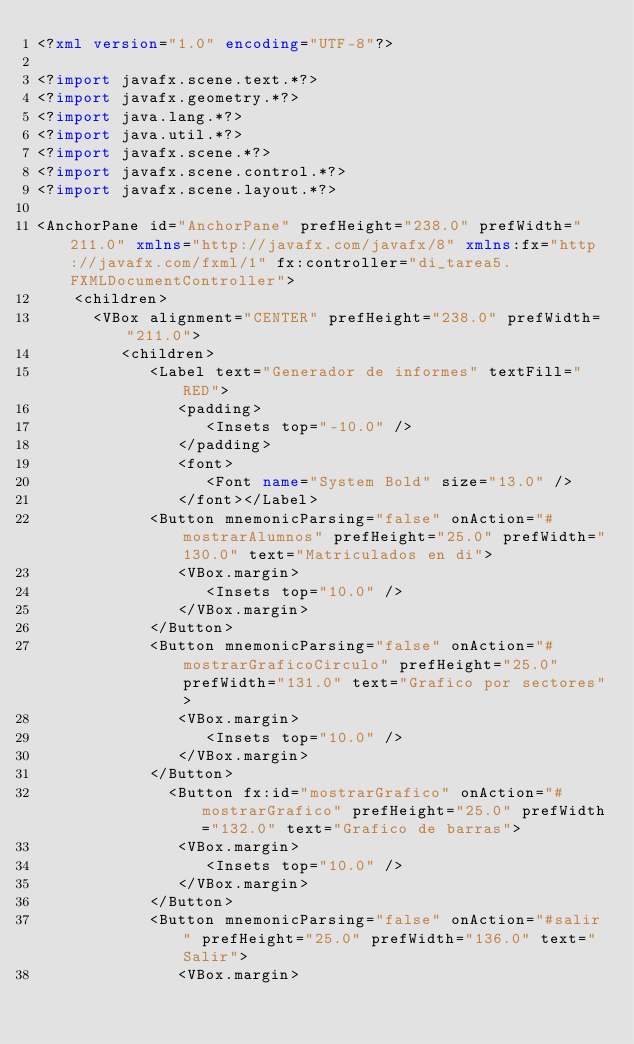Convert code to text. <code><loc_0><loc_0><loc_500><loc_500><_XML_><?xml version="1.0" encoding="UTF-8"?>

<?import javafx.scene.text.*?>
<?import javafx.geometry.*?>
<?import java.lang.*?>
<?import java.util.*?>
<?import javafx.scene.*?>
<?import javafx.scene.control.*?>
<?import javafx.scene.layout.*?>

<AnchorPane id="AnchorPane" prefHeight="238.0" prefWidth="211.0" xmlns="http://javafx.com/javafx/8" xmlns:fx="http://javafx.com/fxml/1" fx:controller="di_tarea5.FXMLDocumentController">
    <children>
      <VBox alignment="CENTER" prefHeight="238.0" prefWidth="211.0">
         <children>
            <Label text="Generador de informes" textFill="RED">
               <padding>
                  <Insets top="-10.0" />
               </padding>
               <font>
                  <Font name="System Bold" size="13.0" />
               </font></Label>
            <Button mnemonicParsing="false" onAction="#mostrarAlumnos" prefHeight="25.0" prefWidth="130.0" text="Matriculados en di">
               <VBox.margin>
                  <Insets top="10.0" />
               </VBox.margin>
            </Button>
            <Button mnemonicParsing="false" onAction="#mostrarGraficoCirculo" prefHeight="25.0" prefWidth="131.0" text="Grafico por sectores">
               <VBox.margin>
                  <Insets top="10.0" />
               </VBox.margin>
            </Button>
              <Button fx:id="mostrarGrafico" onAction="#mostrarGrafico" prefHeight="25.0" prefWidth="132.0" text="Grafico de barras">
               <VBox.margin>
                  <Insets top="10.0" />
               </VBox.margin>
            </Button>
            <Button mnemonicParsing="false" onAction="#salir" prefHeight="25.0" prefWidth="136.0" text="Salir">
               <VBox.margin></code> 